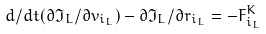<formula> <loc_0><loc_0><loc_500><loc_500>d / d t ( { \partial } { \Im } _ { L } / { \partial } v _ { i _ { L } } ) - { \partial } { \Im } _ { L } / { \partial } r _ { i _ { L } } = - F _ { i _ { L } } ^ { K }</formula> 